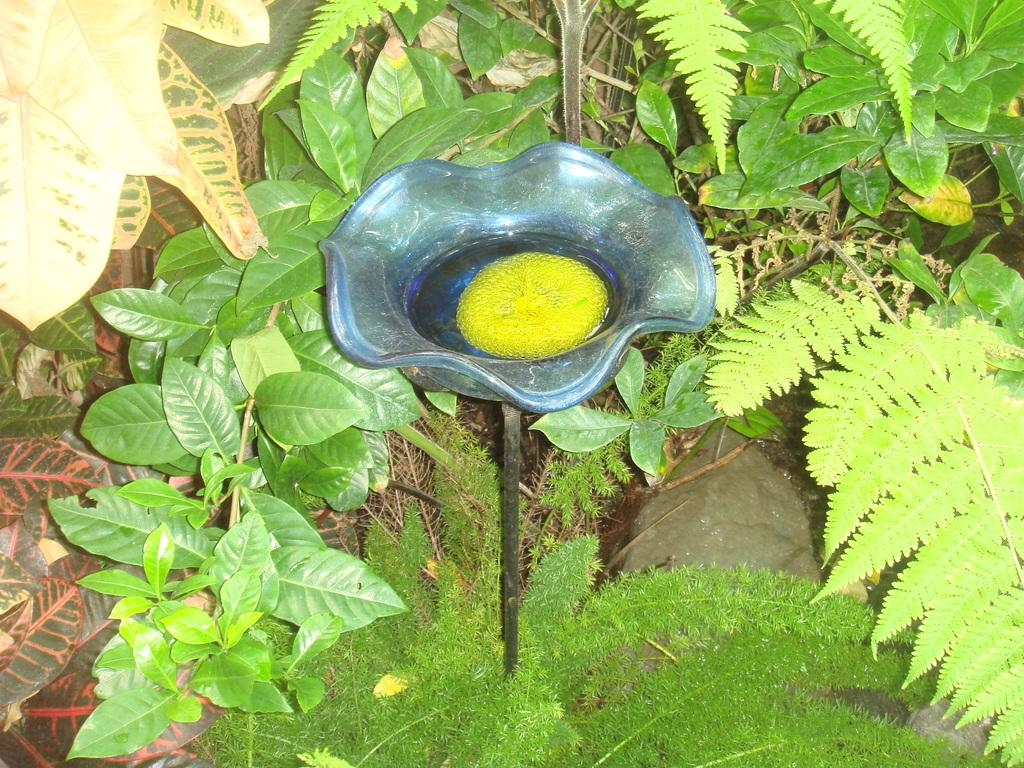What type of living organisms can be seen in the image? Plants and leaves are visible in the image. What color is the object that is attached to a pole? The object is blue. What is inside the blue object? There is something inside the blue object. How is the blue object connected to the pole? The blue object is attached to a pole. How many crates are stacked on top of the bike in the image? There is no crate or bike present in the image. 